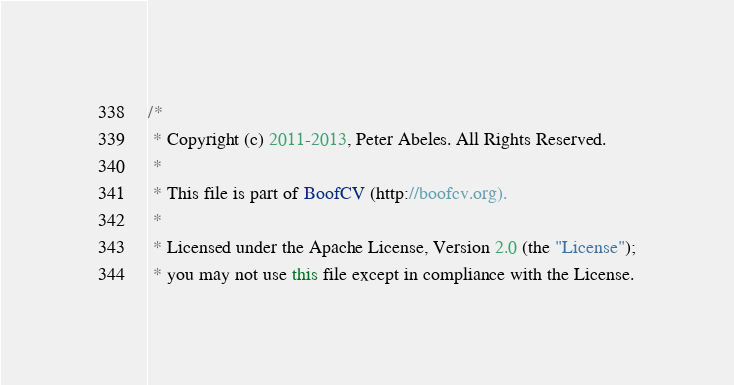Convert code to text. <code><loc_0><loc_0><loc_500><loc_500><_Java_>/*
 * Copyright (c) 2011-2013, Peter Abeles. All Rights Reserved.
 *
 * This file is part of BoofCV (http://boofcv.org).
 *
 * Licensed under the Apache License, Version 2.0 (the "License");
 * you may not use this file except in compliance with the License.</code> 